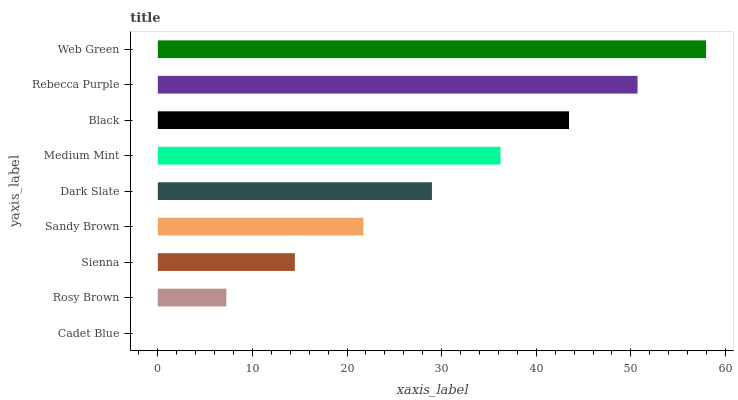Is Cadet Blue the minimum?
Answer yes or no. Yes. Is Web Green the maximum?
Answer yes or no. Yes. Is Rosy Brown the minimum?
Answer yes or no. No. Is Rosy Brown the maximum?
Answer yes or no. No. Is Rosy Brown greater than Cadet Blue?
Answer yes or no. Yes. Is Cadet Blue less than Rosy Brown?
Answer yes or no. Yes. Is Cadet Blue greater than Rosy Brown?
Answer yes or no. No. Is Rosy Brown less than Cadet Blue?
Answer yes or no. No. Is Dark Slate the high median?
Answer yes or no. Yes. Is Dark Slate the low median?
Answer yes or no. Yes. Is Medium Mint the high median?
Answer yes or no. No. Is Sandy Brown the low median?
Answer yes or no. No. 